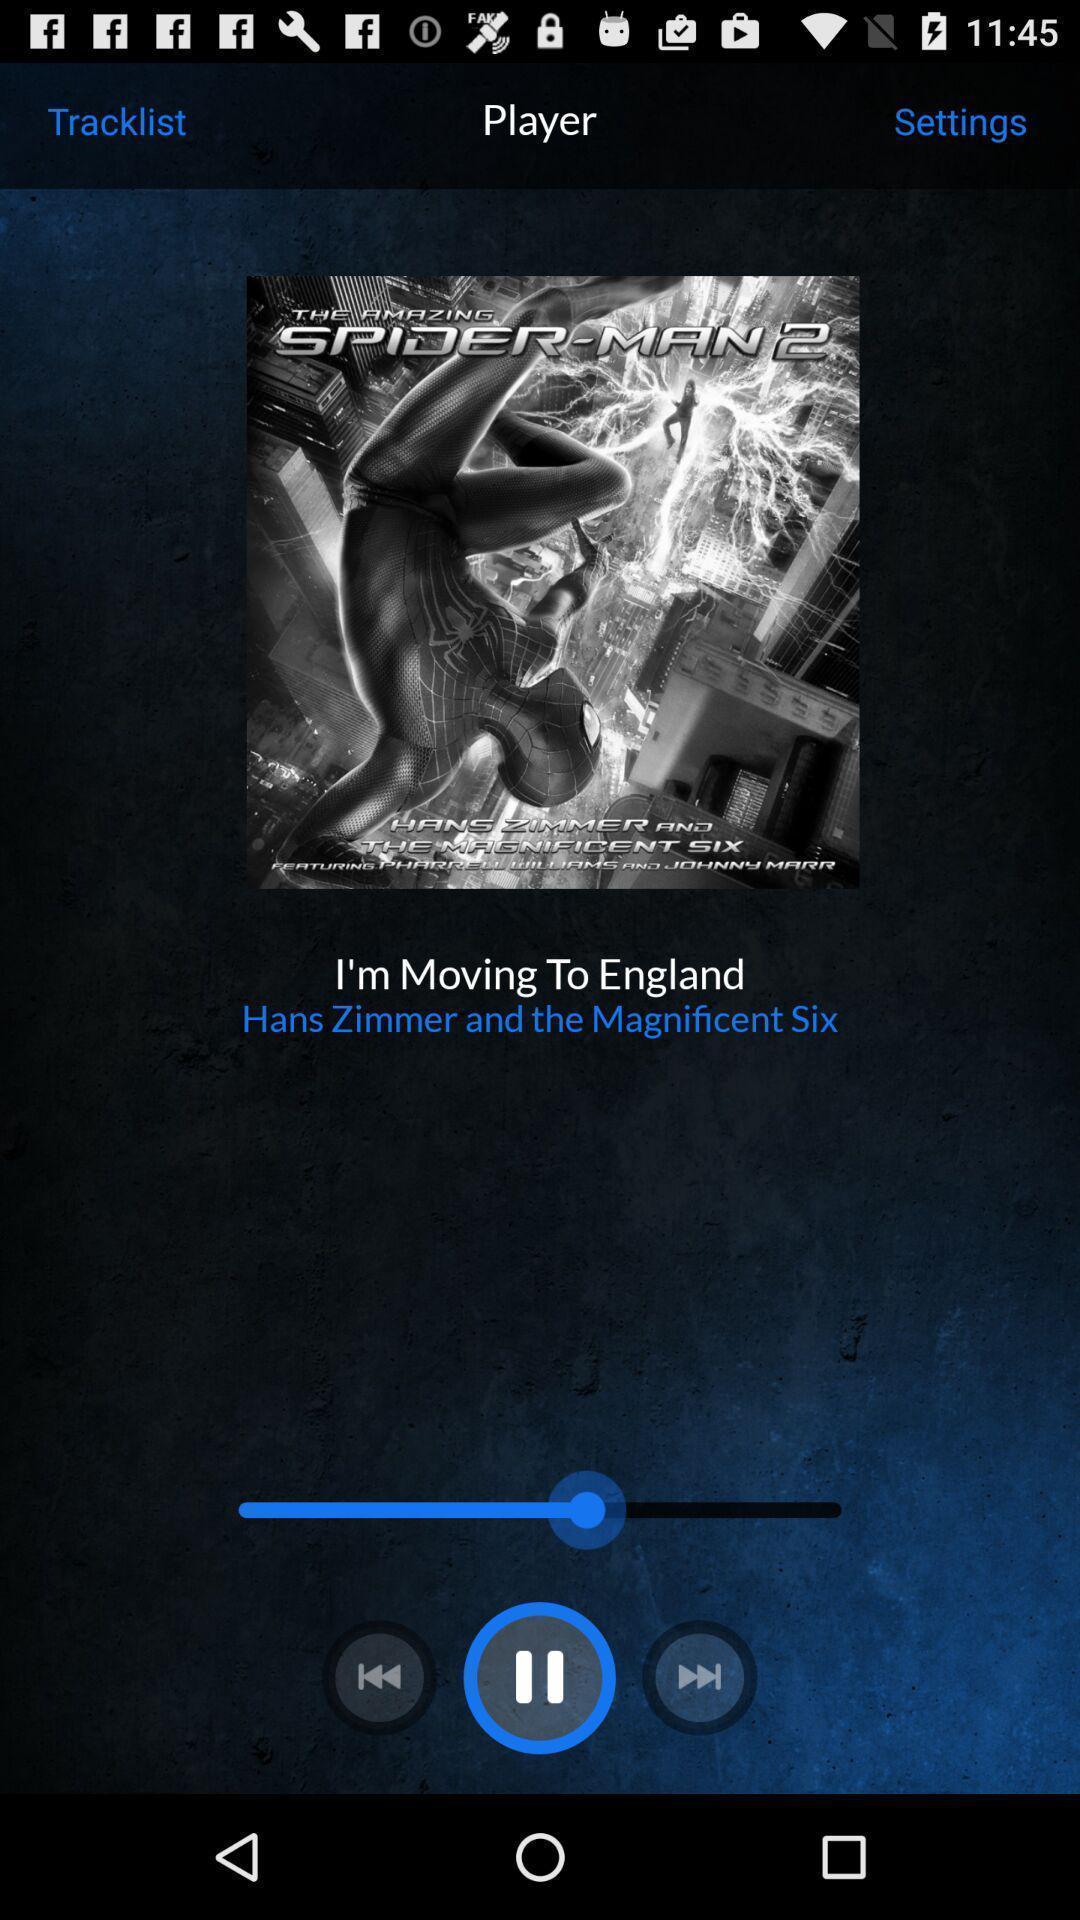Explain the elements present in this screenshot. Screen showing now playing song in music player app. 